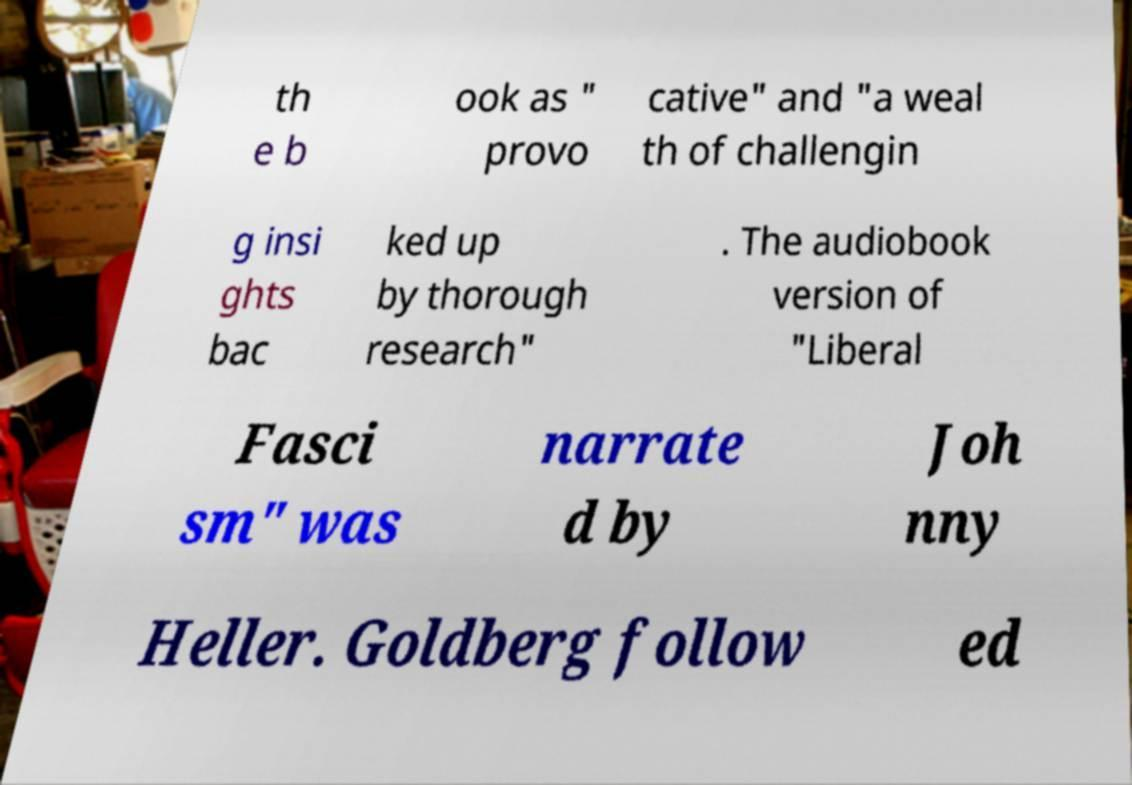I need the written content from this picture converted into text. Can you do that? th e b ook as " provo cative" and "a weal th of challengin g insi ghts bac ked up by thorough research" . The audiobook version of "Liberal Fasci sm" was narrate d by Joh nny Heller. Goldberg follow ed 